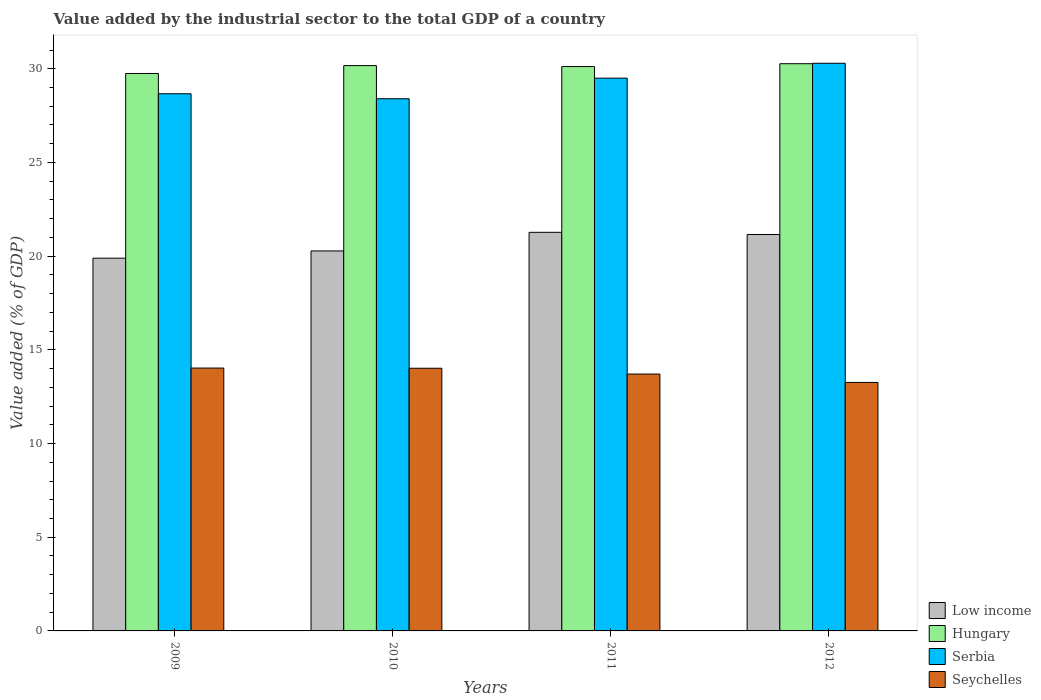Are the number of bars per tick equal to the number of legend labels?
Keep it short and to the point. Yes. Are the number of bars on each tick of the X-axis equal?
Keep it short and to the point. Yes. How many bars are there on the 4th tick from the right?
Provide a short and direct response. 4. What is the label of the 2nd group of bars from the left?
Make the answer very short. 2010. In how many cases, is the number of bars for a given year not equal to the number of legend labels?
Give a very brief answer. 0. What is the value added by the industrial sector to the total GDP in Seychelles in 2009?
Keep it short and to the point. 14.03. Across all years, what is the maximum value added by the industrial sector to the total GDP in Hungary?
Provide a succinct answer. 30.27. Across all years, what is the minimum value added by the industrial sector to the total GDP in Seychelles?
Keep it short and to the point. 13.26. What is the total value added by the industrial sector to the total GDP in Serbia in the graph?
Your answer should be compact. 116.86. What is the difference between the value added by the industrial sector to the total GDP in Low income in 2010 and that in 2012?
Offer a terse response. -0.88. What is the difference between the value added by the industrial sector to the total GDP in Seychelles in 2011 and the value added by the industrial sector to the total GDP in Serbia in 2012?
Keep it short and to the point. -16.59. What is the average value added by the industrial sector to the total GDP in Hungary per year?
Your answer should be compact. 30.08. In the year 2012, what is the difference between the value added by the industrial sector to the total GDP in Low income and value added by the industrial sector to the total GDP in Serbia?
Keep it short and to the point. -9.14. In how many years, is the value added by the industrial sector to the total GDP in Serbia greater than 11 %?
Provide a short and direct response. 4. What is the ratio of the value added by the industrial sector to the total GDP in Seychelles in 2009 to that in 2012?
Offer a very short reply. 1.06. Is the value added by the industrial sector to the total GDP in Seychelles in 2009 less than that in 2012?
Keep it short and to the point. No. Is the difference between the value added by the industrial sector to the total GDP in Low income in 2009 and 2012 greater than the difference between the value added by the industrial sector to the total GDP in Serbia in 2009 and 2012?
Your response must be concise. Yes. What is the difference between the highest and the second highest value added by the industrial sector to the total GDP in Low income?
Offer a terse response. 0.12. What is the difference between the highest and the lowest value added by the industrial sector to the total GDP in Seychelles?
Your answer should be compact. 0.77. In how many years, is the value added by the industrial sector to the total GDP in Serbia greater than the average value added by the industrial sector to the total GDP in Serbia taken over all years?
Your answer should be compact. 2. Is the sum of the value added by the industrial sector to the total GDP in Serbia in 2010 and 2011 greater than the maximum value added by the industrial sector to the total GDP in Low income across all years?
Provide a short and direct response. Yes. What does the 3rd bar from the right in 2012 represents?
Offer a terse response. Hungary. Is it the case that in every year, the sum of the value added by the industrial sector to the total GDP in Serbia and value added by the industrial sector to the total GDP in Low income is greater than the value added by the industrial sector to the total GDP in Hungary?
Ensure brevity in your answer.  Yes. What is the difference between two consecutive major ticks on the Y-axis?
Ensure brevity in your answer.  5. Does the graph contain grids?
Your answer should be very brief. No. How many legend labels are there?
Offer a very short reply. 4. How are the legend labels stacked?
Make the answer very short. Vertical. What is the title of the graph?
Your response must be concise. Value added by the industrial sector to the total GDP of a country. What is the label or title of the X-axis?
Make the answer very short. Years. What is the label or title of the Y-axis?
Provide a succinct answer. Value added (% of GDP). What is the Value added (% of GDP) of Low income in 2009?
Your answer should be compact. 19.89. What is the Value added (% of GDP) of Hungary in 2009?
Your answer should be very brief. 29.75. What is the Value added (% of GDP) in Serbia in 2009?
Your response must be concise. 28.67. What is the Value added (% of GDP) in Seychelles in 2009?
Ensure brevity in your answer.  14.03. What is the Value added (% of GDP) of Low income in 2010?
Provide a short and direct response. 20.28. What is the Value added (% of GDP) in Hungary in 2010?
Offer a terse response. 30.17. What is the Value added (% of GDP) in Serbia in 2010?
Offer a terse response. 28.4. What is the Value added (% of GDP) in Seychelles in 2010?
Make the answer very short. 14.02. What is the Value added (% of GDP) in Low income in 2011?
Ensure brevity in your answer.  21.27. What is the Value added (% of GDP) of Hungary in 2011?
Your response must be concise. 30.12. What is the Value added (% of GDP) in Serbia in 2011?
Your response must be concise. 29.5. What is the Value added (% of GDP) of Seychelles in 2011?
Your answer should be compact. 13.71. What is the Value added (% of GDP) in Low income in 2012?
Offer a very short reply. 21.16. What is the Value added (% of GDP) of Hungary in 2012?
Your answer should be compact. 30.27. What is the Value added (% of GDP) of Serbia in 2012?
Provide a succinct answer. 30.29. What is the Value added (% of GDP) in Seychelles in 2012?
Provide a succinct answer. 13.26. Across all years, what is the maximum Value added (% of GDP) in Low income?
Ensure brevity in your answer.  21.27. Across all years, what is the maximum Value added (% of GDP) of Hungary?
Your answer should be compact. 30.27. Across all years, what is the maximum Value added (% of GDP) of Serbia?
Give a very brief answer. 30.29. Across all years, what is the maximum Value added (% of GDP) of Seychelles?
Offer a terse response. 14.03. Across all years, what is the minimum Value added (% of GDP) in Low income?
Provide a succinct answer. 19.89. Across all years, what is the minimum Value added (% of GDP) of Hungary?
Offer a very short reply. 29.75. Across all years, what is the minimum Value added (% of GDP) in Serbia?
Provide a short and direct response. 28.4. Across all years, what is the minimum Value added (% of GDP) of Seychelles?
Your response must be concise. 13.26. What is the total Value added (% of GDP) of Low income in the graph?
Offer a terse response. 82.6. What is the total Value added (% of GDP) of Hungary in the graph?
Your answer should be very brief. 120.3. What is the total Value added (% of GDP) in Serbia in the graph?
Provide a short and direct response. 116.86. What is the total Value added (% of GDP) in Seychelles in the graph?
Keep it short and to the point. 55.01. What is the difference between the Value added (% of GDP) in Low income in 2009 and that in 2010?
Make the answer very short. -0.39. What is the difference between the Value added (% of GDP) in Hungary in 2009 and that in 2010?
Offer a very short reply. -0.42. What is the difference between the Value added (% of GDP) in Serbia in 2009 and that in 2010?
Offer a terse response. 0.27. What is the difference between the Value added (% of GDP) in Seychelles in 2009 and that in 2010?
Give a very brief answer. 0.01. What is the difference between the Value added (% of GDP) of Low income in 2009 and that in 2011?
Your response must be concise. -1.38. What is the difference between the Value added (% of GDP) of Hungary in 2009 and that in 2011?
Provide a succinct answer. -0.37. What is the difference between the Value added (% of GDP) in Serbia in 2009 and that in 2011?
Your answer should be very brief. -0.83. What is the difference between the Value added (% of GDP) of Seychelles in 2009 and that in 2011?
Your answer should be compact. 0.32. What is the difference between the Value added (% of GDP) of Low income in 2009 and that in 2012?
Give a very brief answer. -1.26. What is the difference between the Value added (% of GDP) in Hungary in 2009 and that in 2012?
Give a very brief answer. -0.52. What is the difference between the Value added (% of GDP) of Serbia in 2009 and that in 2012?
Ensure brevity in your answer.  -1.63. What is the difference between the Value added (% of GDP) of Seychelles in 2009 and that in 2012?
Offer a very short reply. 0.77. What is the difference between the Value added (% of GDP) of Low income in 2010 and that in 2011?
Provide a succinct answer. -0.99. What is the difference between the Value added (% of GDP) of Hungary in 2010 and that in 2011?
Provide a succinct answer. 0.05. What is the difference between the Value added (% of GDP) of Serbia in 2010 and that in 2011?
Your response must be concise. -1.1. What is the difference between the Value added (% of GDP) in Seychelles in 2010 and that in 2011?
Your answer should be very brief. 0.31. What is the difference between the Value added (% of GDP) of Low income in 2010 and that in 2012?
Give a very brief answer. -0.88. What is the difference between the Value added (% of GDP) in Hungary in 2010 and that in 2012?
Make the answer very short. -0.1. What is the difference between the Value added (% of GDP) of Serbia in 2010 and that in 2012?
Keep it short and to the point. -1.89. What is the difference between the Value added (% of GDP) in Seychelles in 2010 and that in 2012?
Ensure brevity in your answer.  0.76. What is the difference between the Value added (% of GDP) of Low income in 2011 and that in 2012?
Offer a very short reply. 0.12. What is the difference between the Value added (% of GDP) in Hungary in 2011 and that in 2012?
Provide a succinct answer. -0.15. What is the difference between the Value added (% of GDP) of Serbia in 2011 and that in 2012?
Provide a short and direct response. -0.79. What is the difference between the Value added (% of GDP) of Seychelles in 2011 and that in 2012?
Offer a terse response. 0.45. What is the difference between the Value added (% of GDP) of Low income in 2009 and the Value added (% of GDP) of Hungary in 2010?
Make the answer very short. -10.28. What is the difference between the Value added (% of GDP) in Low income in 2009 and the Value added (% of GDP) in Serbia in 2010?
Your response must be concise. -8.51. What is the difference between the Value added (% of GDP) of Low income in 2009 and the Value added (% of GDP) of Seychelles in 2010?
Offer a very short reply. 5.87. What is the difference between the Value added (% of GDP) of Hungary in 2009 and the Value added (% of GDP) of Serbia in 2010?
Provide a succinct answer. 1.35. What is the difference between the Value added (% of GDP) of Hungary in 2009 and the Value added (% of GDP) of Seychelles in 2010?
Provide a short and direct response. 15.73. What is the difference between the Value added (% of GDP) of Serbia in 2009 and the Value added (% of GDP) of Seychelles in 2010?
Your response must be concise. 14.65. What is the difference between the Value added (% of GDP) in Low income in 2009 and the Value added (% of GDP) in Hungary in 2011?
Your answer should be very brief. -10.23. What is the difference between the Value added (% of GDP) of Low income in 2009 and the Value added (% of GDP) of Serbia in 2011?
Make the answer very short. -9.61. What is the difference between the Value added (% of GDP) of Low income in 2009 and the Value added (% of GDP) of Seychelles in 2011?
Your response must be concise. 6.18. What is the difference between the Value added (% of GDP) in Hungary in 2009 and the Value added (% of GDP) in Serbia in 2011?
Provide a short and direct response. 0.25. What is the difference between the Value added (% of GDP) of Hungary in 2009 and the Value added (% of GDP) of Seychelles in 2011?
Keep it short and to the point. 16.04. What is the difference between the Value added (% of GDP) of Serbia in 2009 and the Value added (% of GDP) of Seychelles in 2011?
Ensure brevity in your answer.  14.96. What is the difference between the Value added (% of GDP) of Low income in 2009 and the Value added (% of GDP) of Hungary in 2012?
Provide a succinct answer. -10.38. What is the difference between the Value added (% of GDP) of Low income in 2009 and the Value added (% of GDP) of Serbia in 2012?
Your answer should be compact. -10.4. What is the difference between the Value added (% of GDP) of Low income in 2009 and the Value added (% of GDP) of Seychelles in 2012?
Your response must be concise. 6.63. What is the difference between the Value added (% of GDP) of Hungary in 2009 and the Value added (% of GDP) of Serbia in 2012?
Your answer should be compact. -0.55. What is the difference between the Value added (% of GDP) of Hungary in 2009 and the Value added (% of GDP) of Seychelles in 2012?
Offer a terse response. 16.49. What is the difference between the Value added (% of GDP) in Serbia in 2009 and the Value added (% of GDP) in Seychelles in 2012?
Your answer should be compact. 15.4. What is the difference between the Value added (% of GDP) in Low income in 2010 and the Value added (% of GDP) in Hungary in 2011?
Make the answer very short. -9.84. What is the difference between the Value added (% of GDP) in Low income in 2010 and the Value added (% of GDP) in Serbia in 2011?
Keep it short and to the point. -9.22. What is the difference between the Value added (% of GDP) in Low income in 2010 and the Value added (% of GDP) in Seychelles in 2011?
Your answer should be very brief. 6.57. What is the difference between the Value added (% of GDP) of Hungary in 2010 and the Value added (% of GDP) of Serbia in 2011?
Offer a terse response. 0.67. What is the difference between the Value added (% of GDP) of Hungary in 2010 and the Value added (% of GDP) of Seychelles in 2011?
Provide a short and direct response. 16.46. What is the difference between the Value added (% of GDP) in Serbia in 2010 and the Value added (% of GDP) in Seychelles in 2011?
Make the answer very short. 14.69. What is the difference between the Value added (% of GDP) in Low income in 2010 and the Value added (% of GDP) in Hungary in 2012?
Ensure brevity in your answer.  -9.99. What is the difference between the Value added (% of GDP) of Low income in 2010 and the Value added (% of GDP) of Serbia in 2012?
Offer a terse response. -10.01. What is the difference between the Value added (% of GDP) of Low income in 2010 and the Value added (% of GDP) of Seychelles in 2012?
Make the answer very short. 7.02. What is the difference between the Value added (% of GDP) in Hungary in 2010 and the Value added (% of GDP) in Serbia in 2012?
Your response must be concise. -0.13. What is the difference between the Value added (% of GDP) in Hungary in 2010 and the Value added (% of GDP) in Seychelles in 2012?
Offer a very short reply. 16.91. What is the difference between the Value added (% of GDP) in Serbia in 2010 and the Value added (% of GDP) in Seychelles in 2012?
Offer a terse response. 15.14. What is the difference between the Value added (% of GDP) in Low income in 2011 and the Value added (% of GDP) in Hungary in 2012?
Ensure brevity in your answer.  -9. What is the difference between the Value added (% of GDP) in Low income in 2011 and the Value added (% of GDP) in Serbia in 2012?
Provide a short and direct response. -9.02. What is the difference between the Value added (% of GDP) in Low income in 2011 and the Value added (% of GDP) in Seychelles in 2012?
Your answer should be compact. 8.01. What is the difference between the Value added (% of GDP) of Hungary in 2011 and the Value added (% of GDP) of Serbia in 2012?
Your answer should be compact. -0.18. What is the difference between the Value added (% of GDP) in Hungary in 2011 and the Value added (% of GDP) in Seychelles in 2012?
Give a very brief answer. 16.86. What is the difference between the Value added (% of GDP) of Serbia in 2011 and the Value added (% of GDP) of Seychelles in 2012?
Ensure brevity in your answer.  16.24. What is the average Value added (% of GDP) of Low income per year?
Provide a succinct answer. 20.65. What is the average Value added (% of GDP) of Hungary per year?
Your answer should be very brief. 30.08. What is the average Value added (% of GDP) of Serbia per year?
Make the answer very short. 29.21. What is the average Value added (% of GDP) in Seychelles per year?
Your answer should be very brief. 13.75. In the year 2009, what is the difference between the Value added (% of GDP) of Low income and Value added (% of GDP) of Hungary?
Offer a terse response. -9.86. In the year 2009, what is the difference between the Value added (% of GDP) of Low income and Value added (% of GDP) of Serbia?
Your answer should be very brief. -8.77. In the year 2009, what is the difference between the Value added (% of GDP) of Low income and Value added (% of GDP) of Seychelles?
Your answer should be very brief. 5.86. In the year 2009, what is the difference between the Value added (% of GDP) in Hungary and Value added (% of GDP) in Serbia?
Your answer should be very brief. 1.08. In the year 2009, what is the difference between the Value added (% of GDP) in Hungary and Value added (% of GDP) in Seychelles?
Make the answer very short. 15.72. In the year 2009, what is the difference between the Value added (% of GDP) of Serbia and Value added (% of GDP) of Seychelles?
Provide a succinct answer. 14.64. In the year 2010, what is the difference between the Value added (% of GDP) of Low income and Value added (% of GDP) of Hungary?
Give a very brief answer. -9.89. In the year 2010, what is the difference between the Value added (% of GDP) of Low income and Value added (% of GDP) of Serbia?
Make the answer very short. -8.12. In the year 2010, what is the difference between the Value added (% of GDP) of Low income and Value added (% of GDP) of Seychelles?
Offer a very short reply. 6.26. In the year 2010, what is the difference between the Value added (% of GDP) in Hungary and Value added (% of GDP) in Serbia?
Your answer should be very brief. 1.77. In the year 2010, what is the difference between the Value added (% of GDP) of Hungary and Value added (% of GDP) of Seychelles?
Provide a succinct answer. 16.15. In the year 2010, what is the difference between the Value added (% of GDP) in Serbia and Value added (% of GDP) in Seychelles?
Make the answer very short. 14.38. In the year 2011, what is the difference between the Value added (% of GDP) of Low income and Value added (% of GDP) of Hungary?
Keep it short and to the point. -8.85. In the year 2011, what is the difference between the Value added (% of GDP) in Low income and Value added (% of GDP) in Serbia?
Provide a succinct answer. -8.23. In the year 2011, what is the difference between the Value added (% of GDP) of Low income and Value added (% of GDP) of Seychelles?
Your answer should be very brief. 7.56. In the year 2011, what is the difference between the Value added (% of GDP) of Hungary and Value added (% of GDP) of Serbia?
Ensure brevity in your answer.  0.62. In the year 2011, what is the difference between the Value added (% of GDP) of Hungary and Value added (% of GDP) of Seychelles?
Keep it short and to the point. 16.41. In the year 2011, what is the difference between the Value added (% of GDP) of Serbia and Value added (% of GDP) of Seychelles?
Provide a succinct answer. 15.79. In the year 2012, what is the difference between the Value added (% of GDP) in Low income and Value added (% of GDP) in Hungary?
Provide a succinct answer. -9.11. In the year 2012, what is the difference between the Value added (% of GDP) in Low income and Value added (% of GDP) in Serbia?
Provide a short and direct response. -9.14. In the year 2012, what is the difference between the Value added (% of GDP) of Low income and Value added (% of GDP) of Seychelles?
Keep it short and to the point. 7.89. In the year 2012, what is the difference between the Value added (% of GDP) in Hungary and Value added (% of GDP) in Serbia?
Make the answer very short. -0.02. In the year 2012, what is the difference between the Value added (% of GDP) of Hungary and Value added (% of GDP) of Seychelles?
Provide a succinct answer. 17.01. In the year 2012, what is the difference between the Value added (% of GDP) in Serbia and Value added (% of GDP) in Seychelles?
Your response must be concise. 17.03. What is the ratio of the Value added (% of GDP) in Low income in 2009 to that in 2010?
Give a very brief answer. 0.98. What is the ratio of the Value added (% of GDP) in Hungary in 2009 to that in 2010?
Provide a succinct answer. 0.99. What is the ratio of the Value added (% of GDP) in Serbia in 2009 to that in 2010?
Your answer should be compact. 1.01. What is the ratio of the Value added (% of GDP) in Seychelles in 2009 to that in 2010?
Give a very brief answer. 1. What is the ratio of the Value added (% of GDP) of Low income in 2009 to that in 2011?
Your answer should be very brief. 0.94. What is the ratio of the Value added (% of GDP) in Serbia in 2009 to that in 2011?
Your answer should be compact. 0.97. What is the ratio of the Value added (% of GDP) in Seychelles in 2009 to that in 2011?
Your answer should be very brief. 1.02. What is the ratio of the Value added (% of GDP) in Low income in 2009 to that in 2012?
Provide a short and direct response. 0.94. What is the ratio of the Value added (% of GDP) in Hungary in 2009 to that in 2012?
Offer a terse response. 0.98. What is the ratio of the Value added (% of GDP) of Serbia in 2009 to that in 2012?
Make the answer very short. 0.95. What is the ratio of the Value added (% of GDP) in Seychelles in 2009 to that in 2012?
Keep it short and to the point. 1.06. What is the ratio of the Value added (% of GDP) of Low income in 2010 to that in 2011?
Provide a succinct answer. 0.95. What is the ratio of the Value added (% of GDP) of Hungary in 2010 to that in 2011?
Provide a short and direct response. 1. What is the ratio of the Value added (% of GDP) in Serbia in 2010 to that in 2011?
Give a very brief answer. 0.96. What is the ratio of the Value added (% of GDP) in Seychelles in 2010 to that in 2011?
Your response must be concise. 1.02. What is the ratio of the Value added (% of GDP) of Low income in 2010 to that in 2012?
Make the answer very short. 0.96. What is the ratio of the Value added (% of GDP) of Hungary in 2010 to that in 2012?
Provide a short and direct response. 1. What is the ratio of the Value added (% of GDP) in Serbia in 2010 to that in 2012?
Provide a short and direct response. 0.94. What is the ratio of the Value added (% of GDP) in Seychelles in 2010 to that in 2012?
Offer a very short reply. 1.06. What is the ratio of the Value added (% of GDP) in Hungary in 2011 to that in 2012?
Offer a very short reply. 0.99. What is the ratio of the Value added (% of GDP) in Serbia in 2011 to that in 2012?
Your response must be concise. 0.97. What is the ratio of the Value added (% of GDP) in Seychelles in 2011 to that in 2012?
Offer a terse response. 1.03. What is the difference between the highest and the second highest Value added (% of GDP) of Low income?
Provide a succinct answer. 0.12. What is the difference between the highest and the second highest Value added (% of GDP) in Hungary?
Offer a terse response. 0.1. What is the difference between the highest and the second highest Value added (% of GDP) of Serbia?
Provide a succinct answer. 0.79. What is the difference between the highest and the second highest Value added (% of GDP) of Seychelles?
Ensure brevity in your answer.  0.01. What is the difference between the highest and the lowest Value added (% of GDP) in Low income?
Ensure brevity in your answer.  1.38. What is the difference between the highest and the lowest Value added (% of GDP) in Hungary?
Make the answer very short. 0.52. What is the difference between the highest and the lowest Value added (% of GDP) of Serbia?
Give a very brief answer. 1.89. What is the difference between the highest and the lowest Value added (% of GDP) in Seychelles?
Offer a very short reply. 0.77. 